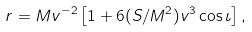<formula> <loc_0><loc_0><loc_500><loc_500>r = M v ^ { - 2 } \left [ 1 + 6 ( S / M ^ { 2 } ) v ^ { 3 } \cos \iota \right ] ,</formula> 